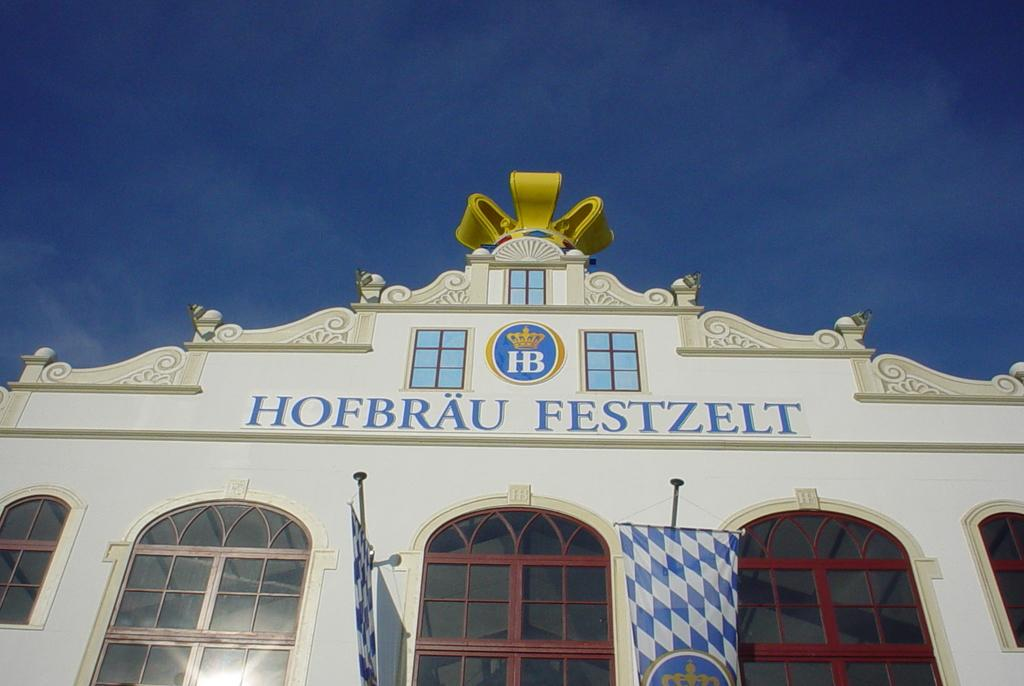What type of structure is present in the image? There is a building in the image. Can you describe the color of the building? The building is white. How many banners are visible in the image? There are two banners in the image. What colors are the banners? One banner is blue and the other is white. What can be seen in the background of the image? The sky is visible in the background of the image. What is the color of the sky? The sky is blue. How does the earth feel about the approval of the new policy in the image? There is no reference to the earth or any policy approval in the image, so it is not possible to answer that question. 